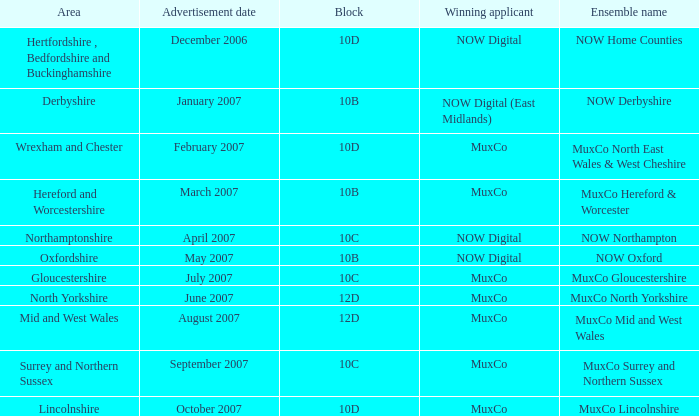Which Block does Northamptonshire Area have? 10C. 